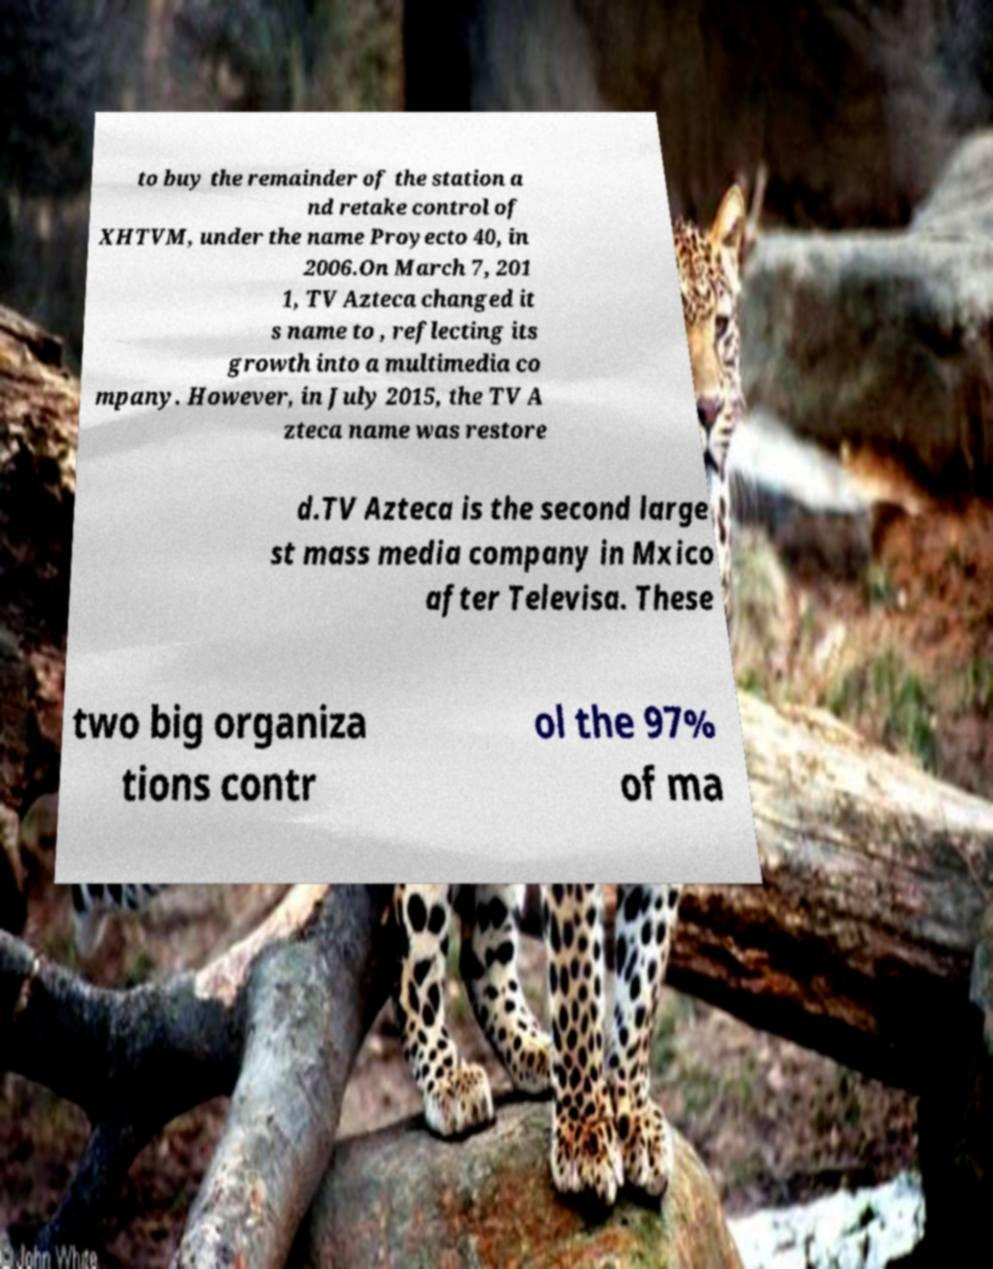What messages or text are displayed in this image? I need them in a readable, typed format. to buy the remainder of the station a nd retake control of XHTVM, under the name Proyecto 40, in 2006.On March 7, 201 1, TV Azteca changed it s name to , reflecting its growth into a multimedia co mpany. However, in July 2015, the TV A zteca name was restore d.TV Azteca is the second large st mass media company in Mxico after Televisa. These two big organiza tions contr ol the 97% of ma 